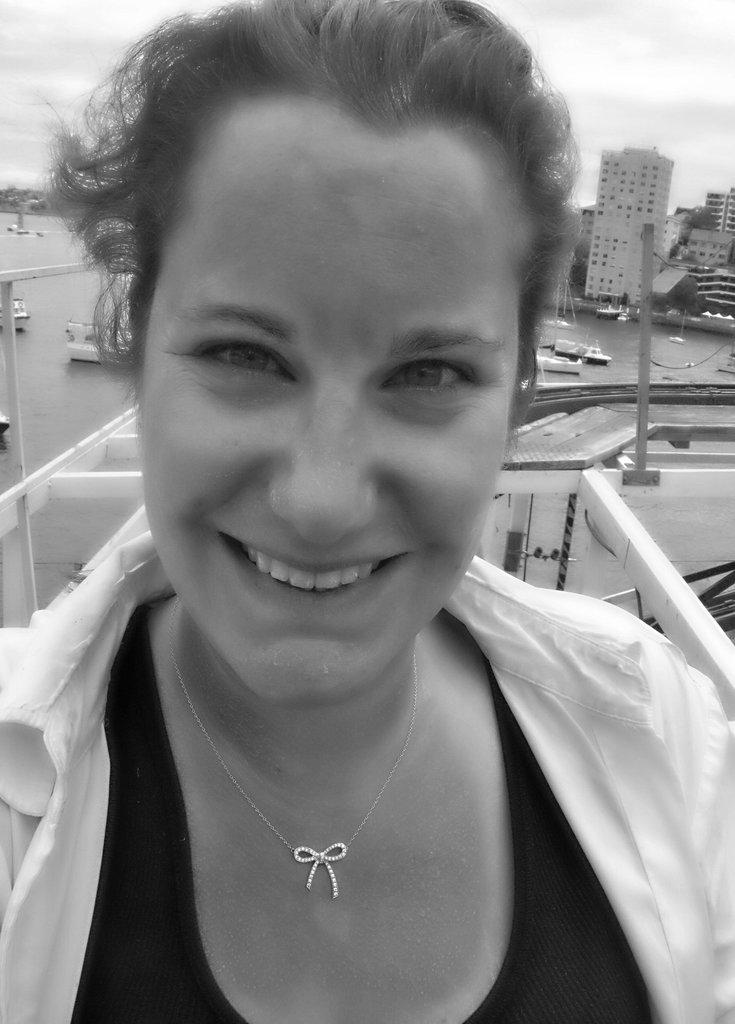What is the color scheme of the image? The image is black and white. Who is present in the image? There is a woman in the image. What can be seen in the background of the image? Buildings, poles, boats in a water body, and the sky are visible in the background. How does the sky appear in the image? The sky appears cloudy in the image. How much cheese is present in the image? There is no cheese present in the image. What nation is represented by the woman in the image? The image does not provide any information about the woman's nationality. 